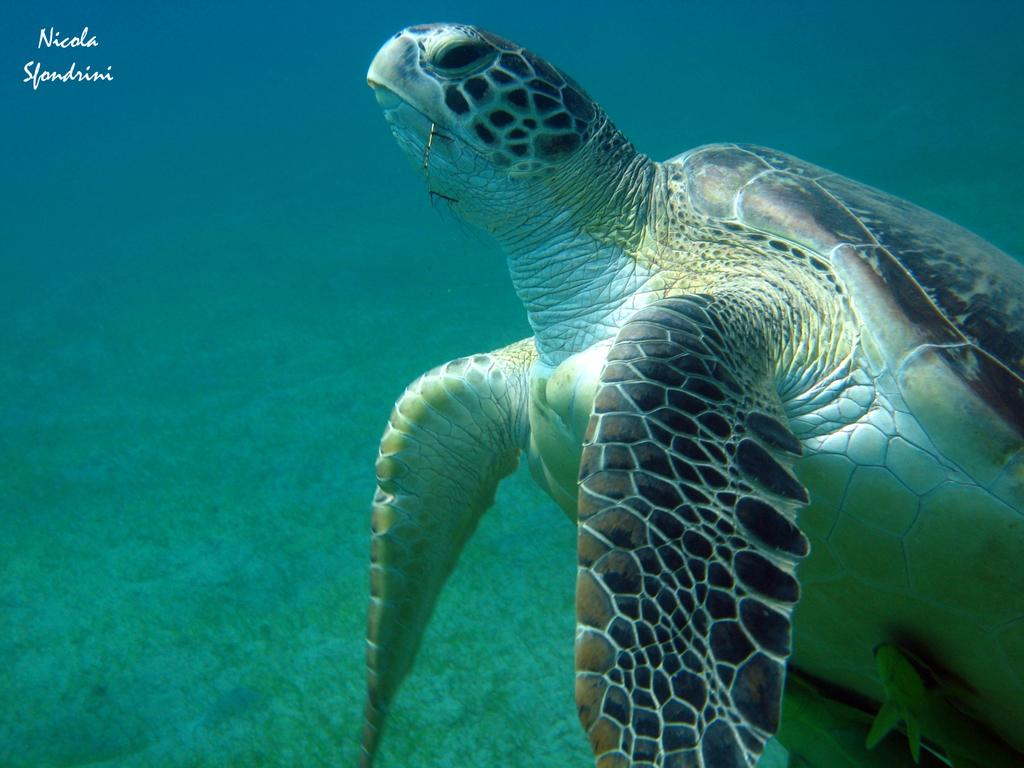What animal is present in the image? There is a turtle in the image. Where is the turtle located in the image? The turtle is under the water. What type of sink can be seen in the image? There is no sink present in the image; it features a turtle underwater. How does the turtle smash the rocks in the image? The turtle does not smash rocks in the image; it is simply under the water. 